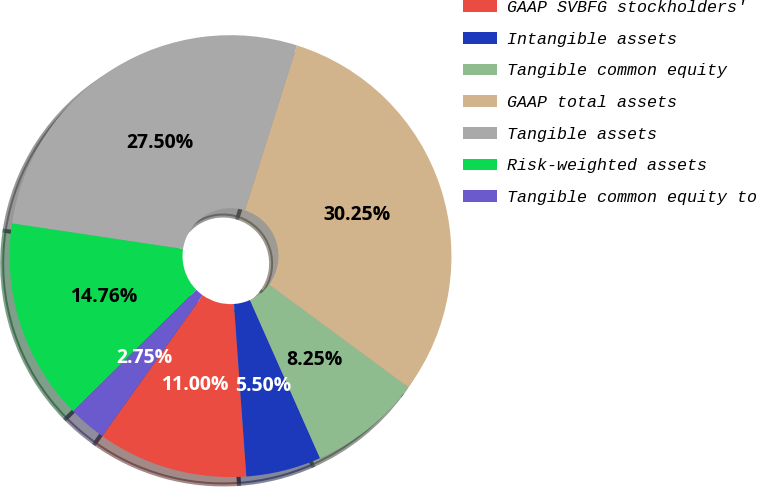Convert chart to OTSL. <chart><loc_0><loc_0><loc_500><loc_500><pie_chart><fcel>GAAP SVBFG stockholders'<fcel>Intangible assets<fcel>Tangible common equity<fcel>GAAP total assets<fcel>Tangible assets<fcel>Risk-weighted assets<fcel>Tangible common equity to<nl><fcel>11.0%<fcel>5.5%<fcel>8.25%<fcel>30.25%<fcel>27.5%<fcel>14.76%<fcel>2.75%<nl></chart> 